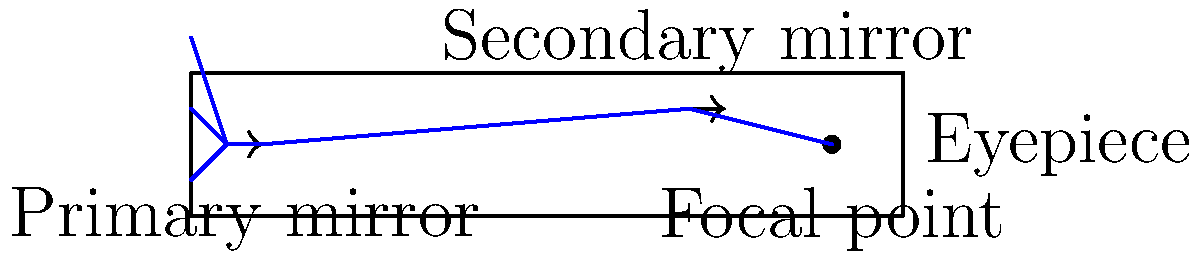In a reflector telescope, explain the path of light from a distant object to the observer's eye, and describe how the primary and secondary mirrors work together to produce a magnified image. How does this design differ from a refractor telescope in terms of optical components and potential advantages? 1. Light path in a reflector telescope:
   a) Light from a distant object enters the open end of the telescope tube.
   b) The light travels to the primary mirror at the back of the tube.
   c) The primary mirror is concave and reflects the light back up the tube.
   d) The reflected light converges towards the secondary mirror.
   e) The secondary mirror, which is flat and angled at 45 degrees, reflects the light to the side of the tube.
   f) The light passes through the eyepiece, where it's magnified for the observer.

2. Role of mirrors:
   a) Primary mirror: Collects and focuses light from distant objects. Its large surface area allows for more light collection, increasing the telescope's light-gathering power.
   b) Secondary mirror: Redirects the focused light to the eyepiece for convenient viewing.

3. Magnification:
   The primary mirror's focal length (f) divided by the eyepiece's focal length (f_e) determines the magnification (M):

   $$ M = \frac{f}{f_e} $$

4. Differences from refractor telescope:
   a) Optical components:
      - Reflector: Uses mirrors (primary and secondary)
      - Refractor: Uses lenses (objective and eyepiece)
   
   b) Advantages of reflector design:
      - Less chromatic aberration (no dispersion in mirrors)
      - Potentially larger apertures at lower cost
      - More compact design for a given focal length
      - No need for regular realignment (collimation) of lenses

5. Potential issues:
   - Reflectors may require occasional realignment of mirrors
   - Central obstruction from secondary mirror slightly reduces contrast

The reflector design allows for larger apertures and better performance for deep-sky observations, making it popular among amateur astronomers and in professional observatories.
Answer: Light enters tube → reflected by primary mirror → redirected by secondary mirror → magnified by eyepiece. Mirrors focus and redirect light, offering larger apertures and less chromatic aberration than refractors. 